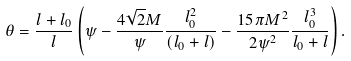Convert formula to latex. <formula><loc_0><loc_0><loc_500><loc_500>\theta = \frac { l + l _ { 0 } } { l } \left ( \psi - \frac { 4 \sqrt { 2 } M } { \psi } \frac { l _ { 0 } ^ { 2 } } { ( l _ { 0 } + l ) } - \frac { 1 5 \pi M ^ { 2 } } { 2 \psi ^ { 2 } } \frac { l _ { 0 } ^ { 3 } } { l _ { 0 } + l } \right ) .</formula> 